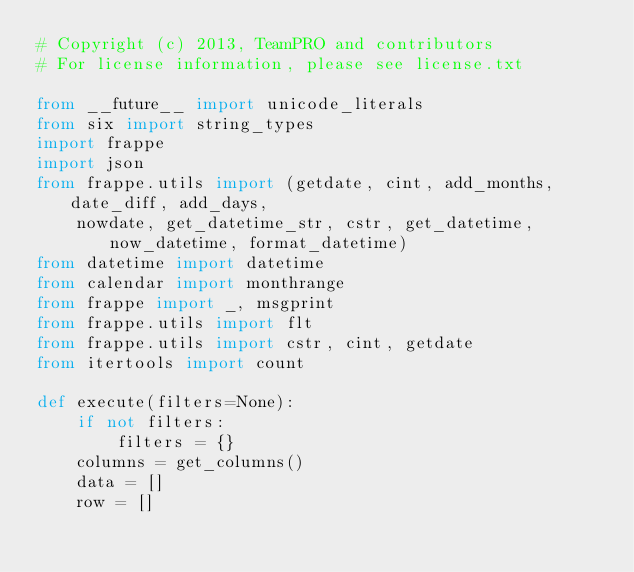Convert code to text. <code><loc_0><loc_0><loc_500><loc_500><_Python_># Copyright (c) 2013, TeamPRO and contributors
# For license information, please see license.txt

from __future__ import unicode_literals
from six import string_types
import frappe
import json
from frappe.utils import (getdate, cint, add_months, date_diff, add_days,
    nowdate, get_datetime_str, cstr, get_datetime, now_datetime, format_datetime)
from datetime import datetime
from calendar import monthrange
from frappe import _, msgprint
from frappe.utils import flt
from frappe.utils import cstr, cint, getdate
from itertools import count

def execute(filters=None):
    if not filters:
        filters = {}
    columns = get_columns()
    data = []
    row = []</code> 